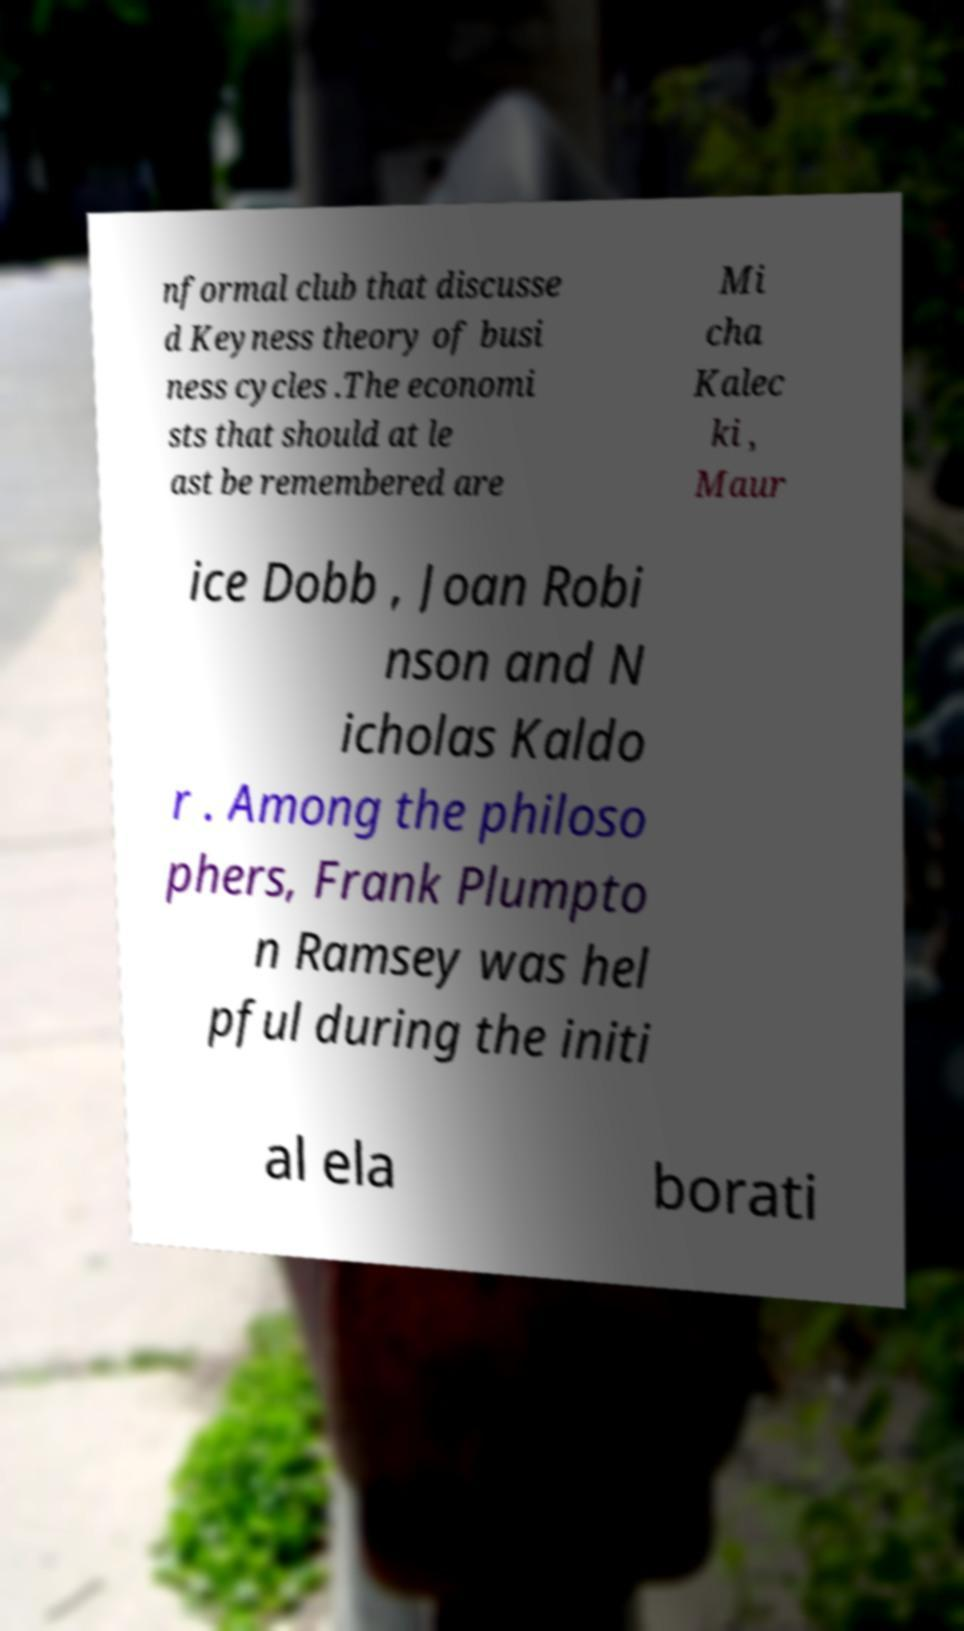Could you assist in decoding the text presented in this image and type it out clearly? nformal club that discusse d Keyness theory of busi ness cycles .The economi sts that should at le ast be remembered are Mi cha Kalec ki , Maur ice Dobb , Joan Robi nson and N icholas Kaldo r . Among the philoso phers, Frank Plumpto n Ramsey was hel pful during the initi al ela borati 